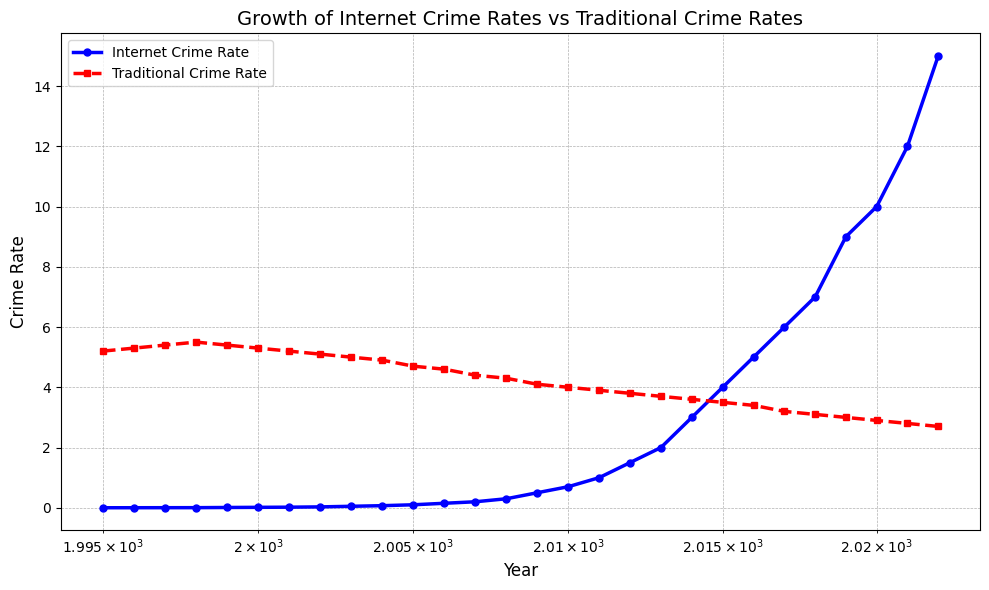what trend do you observe for internet crime rates over the years? Internet crime rates have shown an increasing trend over the years. From 1995 to 2022, the rate grew from 0.001 to 15.000, indicating significant growth in internet crimes. By observing the figure's blue line, you can see a steady upward trajectory.
Answer: Increasing which year shows the highest internet crime rate? By examining the blue line in the plot, the highest marker occurs in the year 2022. The legend indicates that this corresponds to an internet crime rate value.
Answer: 2022 when did the internet crime rate surpass the traditional crime rate? Look at the intersection point of the blue and red lines on the graph. The blue line exceeds the red line right after 2010, indicating that around 2011, the internet crime rate surpasses the traditional crime rate.
Answer: Around 2011 how did traditional crime rates change over the years? Traditional crime rates have shown a decreasing trend over the years. This is evident from the red line, which starts at 5.2 in 1995 and decreases steadily to 2.7 in 2022. The downward slope signifies the reduction in traditional crimes.
Answer: Decreasing how does the change in internet crime rates from 1995 to 2022 compare to the change in traditional crime rates over the same period? Calculate the difference for both: Internet crime rate changes from 0.001 in 1995 to 15.000 in 2022, a change of 14.999 units. Traditional crime rate changes from 5.2 in 1995 to 2.7 in 2022, a change of -2.5 units. Comparing both, internet crime rates increased much more significantly.
Answer: Internet crime rates showed a much larger increase what are the visual indicators that differentiate internet crime rate and traditional crime rate? The internet crime rate is shown by a blue line with circular markers, while the traditional crime rate is represented by a red dashed line with square markers. These visual attributes help distinguish between the two data sets on the chart.
Answer: Line styles and markers what decade saw the most significant rise in internet crime rates? By examining the slope of the blue line, the most significant rise can be identified by the steepest part of the curve. From the graph, this appears to be between 2000 and 2010. Calculating this interval shows the steep slope and rapid increase in internet crime rates.
Answer: 2000-2010 what's the crime rate difference between internet crimes and traditional crimes in 2020? Look at the markers for 2020 on both the blue and red lines. The internet crime rate is 10.000 and traditional crime rate is 2.9. The difference is 10.000 - 2.9 = 7.1.
Answer: 7.1 how does the slope of the internet crime rate compare to that of the traditional crime rate? The slope of the internet crime rate (blue line) is much steeper compared to the slope of the traditional crime rate (red line), indicating a rapid increase in internet crimes versus a slow decrease in traditional crimes. The steepness visually signifies the rapid growth.
Answer: Steeper which crime rate showed more variability over the years? The internet crime rate (blue line) showed more variability, evidenced by its rapid rise and steep slope, compared to the more gradual and consistent decline observed in the traditional crime rate (red line).
Answer: Internet crime rate 